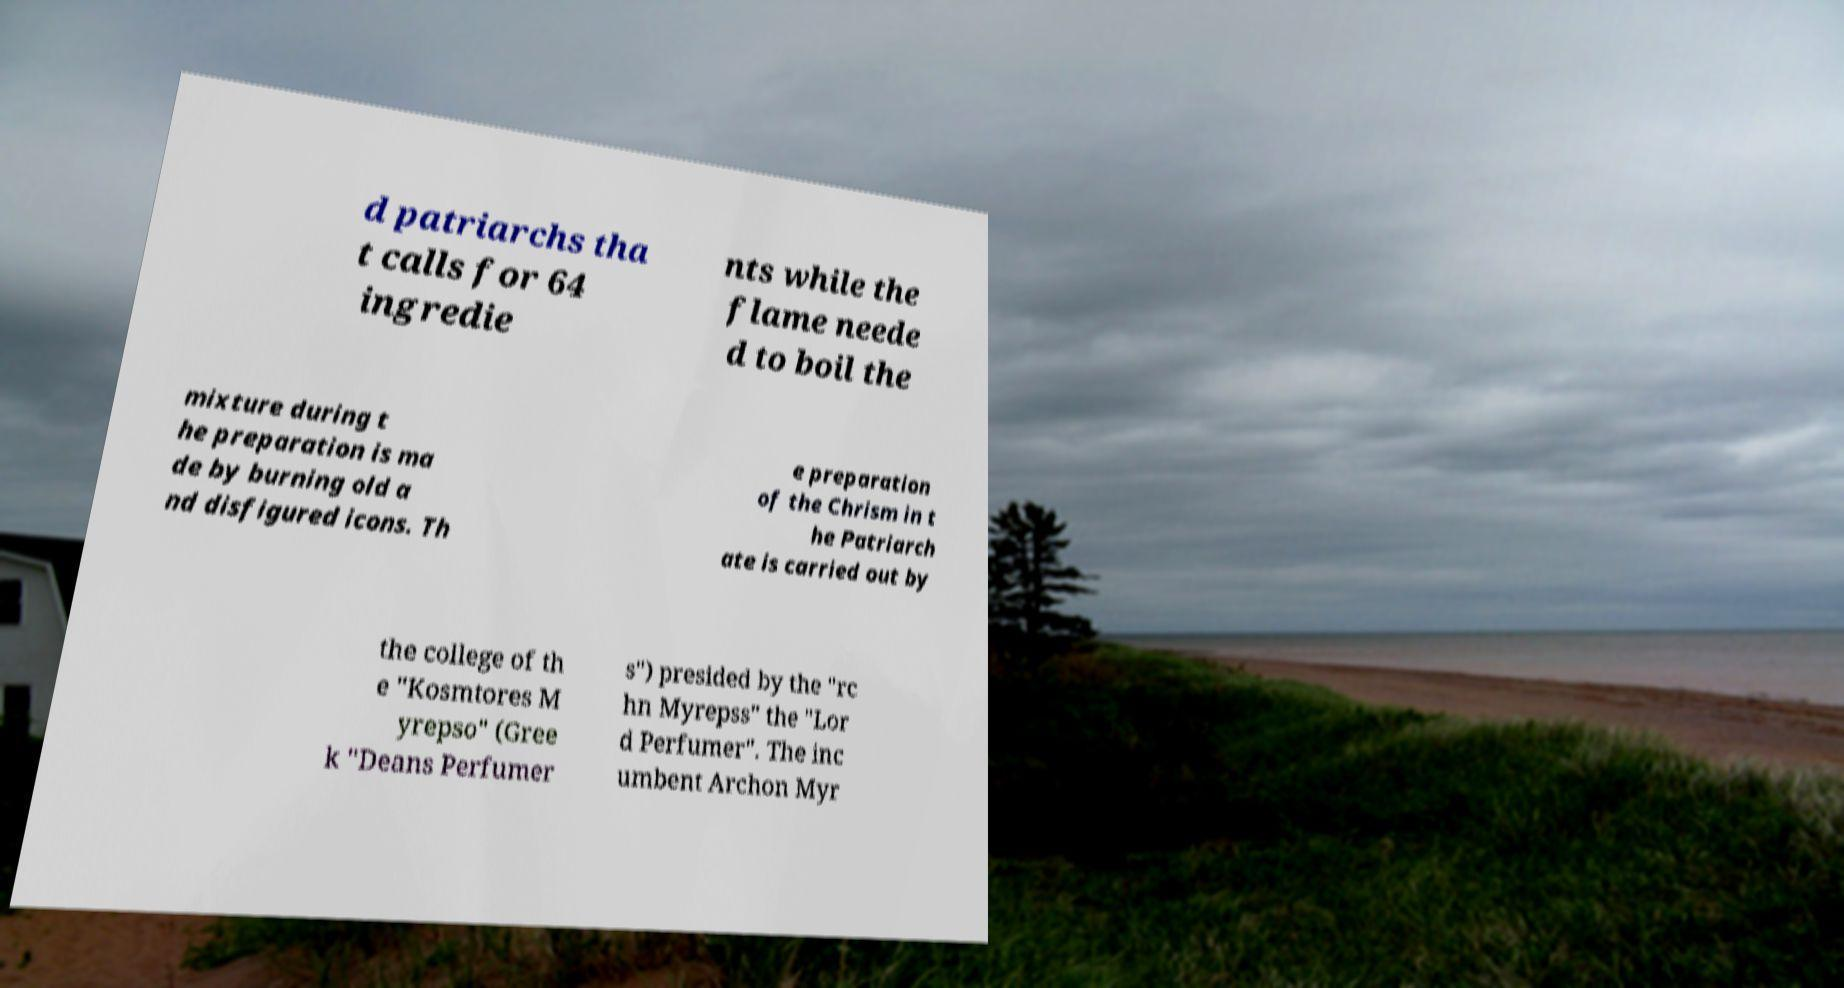Could you extract and type out the text from this image? d patriarchs tha t calls for 64 ingredie nts while the flame neede d to boil the mixture during t he preparation is ma de by burning old a nd disfigured icons. Th e preparation of the Chrism in t he Patriarch ate is carried out by the college of th e "Kosmtores M yrepso" (Gree k "Deans Perfumer s") presided by the "rc hn Myrepss" the "Lor d Perfumer". The inc umbent Archon Myr 